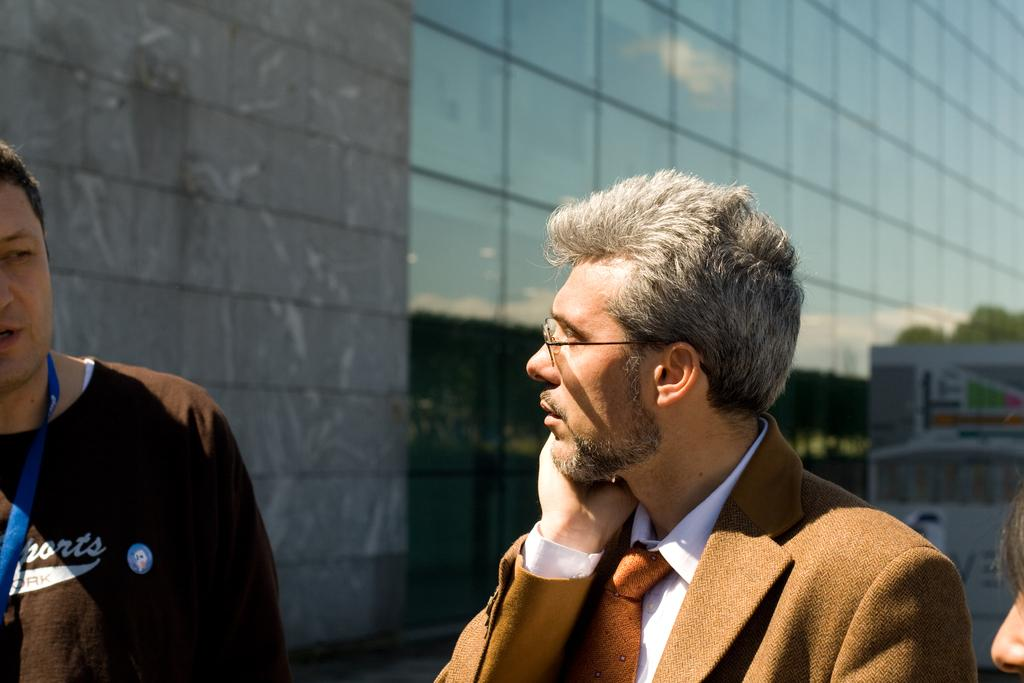Who or what can be seen in the image? There are people in the image. What can be seen in the distance behind the people? There is a building in the background of the image. What object is located on the right side of the image? There is a board on the right side of the image. What type of lettuce is being used to create the government in the image? There is no lettuce or government depicted in the image. 